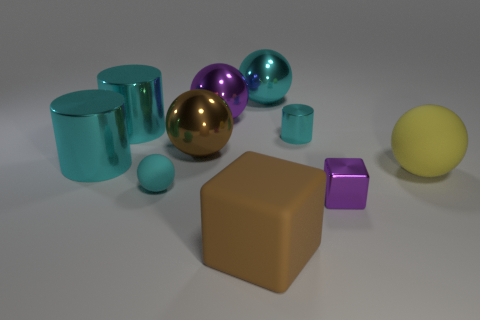The big thing on the right side of the cyan sphere that is behind the big brown shiny sphere in front of the tiny cyan metallic object is what color?
Ensure brevity in your answer.  Yellow. What number of things are tiny red matte objects or metallic spheres?
Provide a succinct answer. 3. What number of tiny blue things have the same shape as the tiny purple metal object?
Your answer should be compact. 0. Is the big purple thing made of the same material as the big cyan object on the right side of the large brown matte block?
Your answer should be compact. Yes. The cyan sphere that is made of the same material as the large brown block is what size?
Your answer should be compact. Small. There is a cyan cylinder to the right of the large brown metal sphere; what size is it?
Offer a terse response. Small. How many other purple metal spheres are the same size as the purple shiny ball?
Make the answer very short. 0. What is the size of the ball that is the same color as the tiny block?
Provide a short and direct response. Large. Is there a tiny rubber thing of the same color as the tiny metallic cube?
Provide a succinct answer. No. What is the color of the other matte ball that is the same size as the purple ball?
Keep it short and to the point. Yellow. 